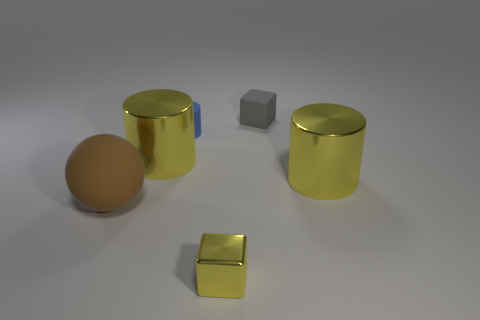Is the color of the small shiny thing that is in front of the small blue object the same as the small matte thing that is left of the gray thing?
Provide a short and direct response. No. How many things are both on the right side of the tiny matte cylinder and in front of the gray cube?
Your answer should be compact. 2. What is the large brown sphere made of?
Make the answer very short. Rubber. There is a gray thing that is the same size as the yellow cube; what is its shape?
Make the answer very short. Cube. Is the material of the big yellow cylinder that is to the left of the gray cube the same as the cylinder that is right of the tiny gray block?
Provide a short and direct response. Yes. What number of yellow cylinders are there?
Ensure brevity in your answer.  2. What number of small yellow things are the same shape as the big rubber object?
Offer a very short reply. 0. Do the gray object and the large rubber object have the same shape?
Your answer should be very brief. No. The brown thing is what size?
Your response must be concise. Large. How many other brown things have the same size as the brown object?
Make the answer very short. 0. 